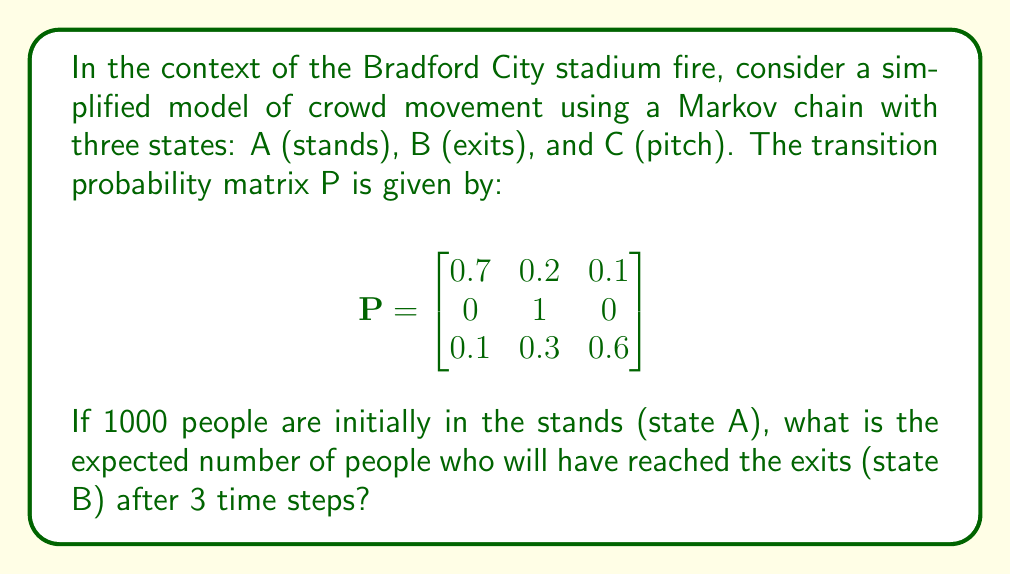Provide a solution to this math problem. To solve this problem, we need to calculate the state distribution after 3 time steps and then focus on the probability of being in state B. Let's proceed step-by-step:

1) The initial state distribution is:
   $$\pi_0 = [1000, 0, 0]$$

2) We need to compute $\pi_3 = \pi_0 P^3$. Let's calculate $P^2$ and $P^3$:

   $$P^2 = \begin{bmatrix}
   0.5 & 0.34 & 0.16 \\
   0 & 1 & 0 \\
   0.13 & 0.48 & 0.39
   \end{bmatrix}$$

   $$P^3 = \begin{bmatrix}
   0.371 & 0.446 & 0.183 \\
   0 & 1 & 0 \\
   0.151 & 0.588 & 0.261
   \end{bmatrix}$$

3) Now we can compute $\pi_3$:

   $$\pi_3 = [1000, 0, 0] \begin{bmatrix}
   0.371 & 0.446 & 0.183 \\
   0 & 1 & 0 \\
   0.151 & 0.588 & 0.261
   \end{bmatrix}$$

   $$\pi_3 = [371, 446, 183]$$

4) The second element of $\pi_3$ represents the expected number of people in state B (exits) after 3 time steps.

Therefore, the expected number of people who will have reached the exits after 3 time steps is 446.
Answer: 446 people 